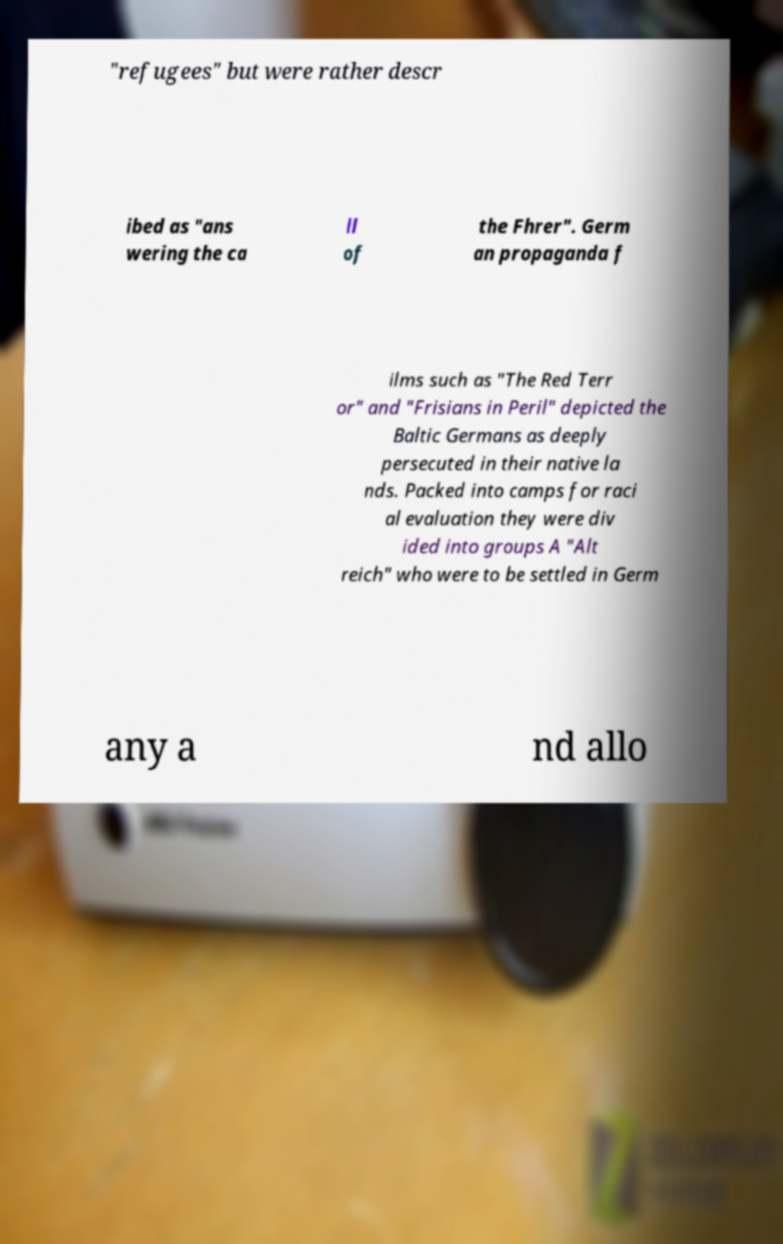Could you extract and type out the text from this image? "refugees" but were rather descr ibed as "ans wering the ca ll of the Fhrer". Germ an propaganda f ilms such as "The Red Terr or" and "Frisians in Peril" depicted the Baltic Germans as deeply persecuted in their native la nds. Packed into camps for raci al evaluation they were div ided into groups A "Alt reich" who were to be settled in Germ any a nd allo 